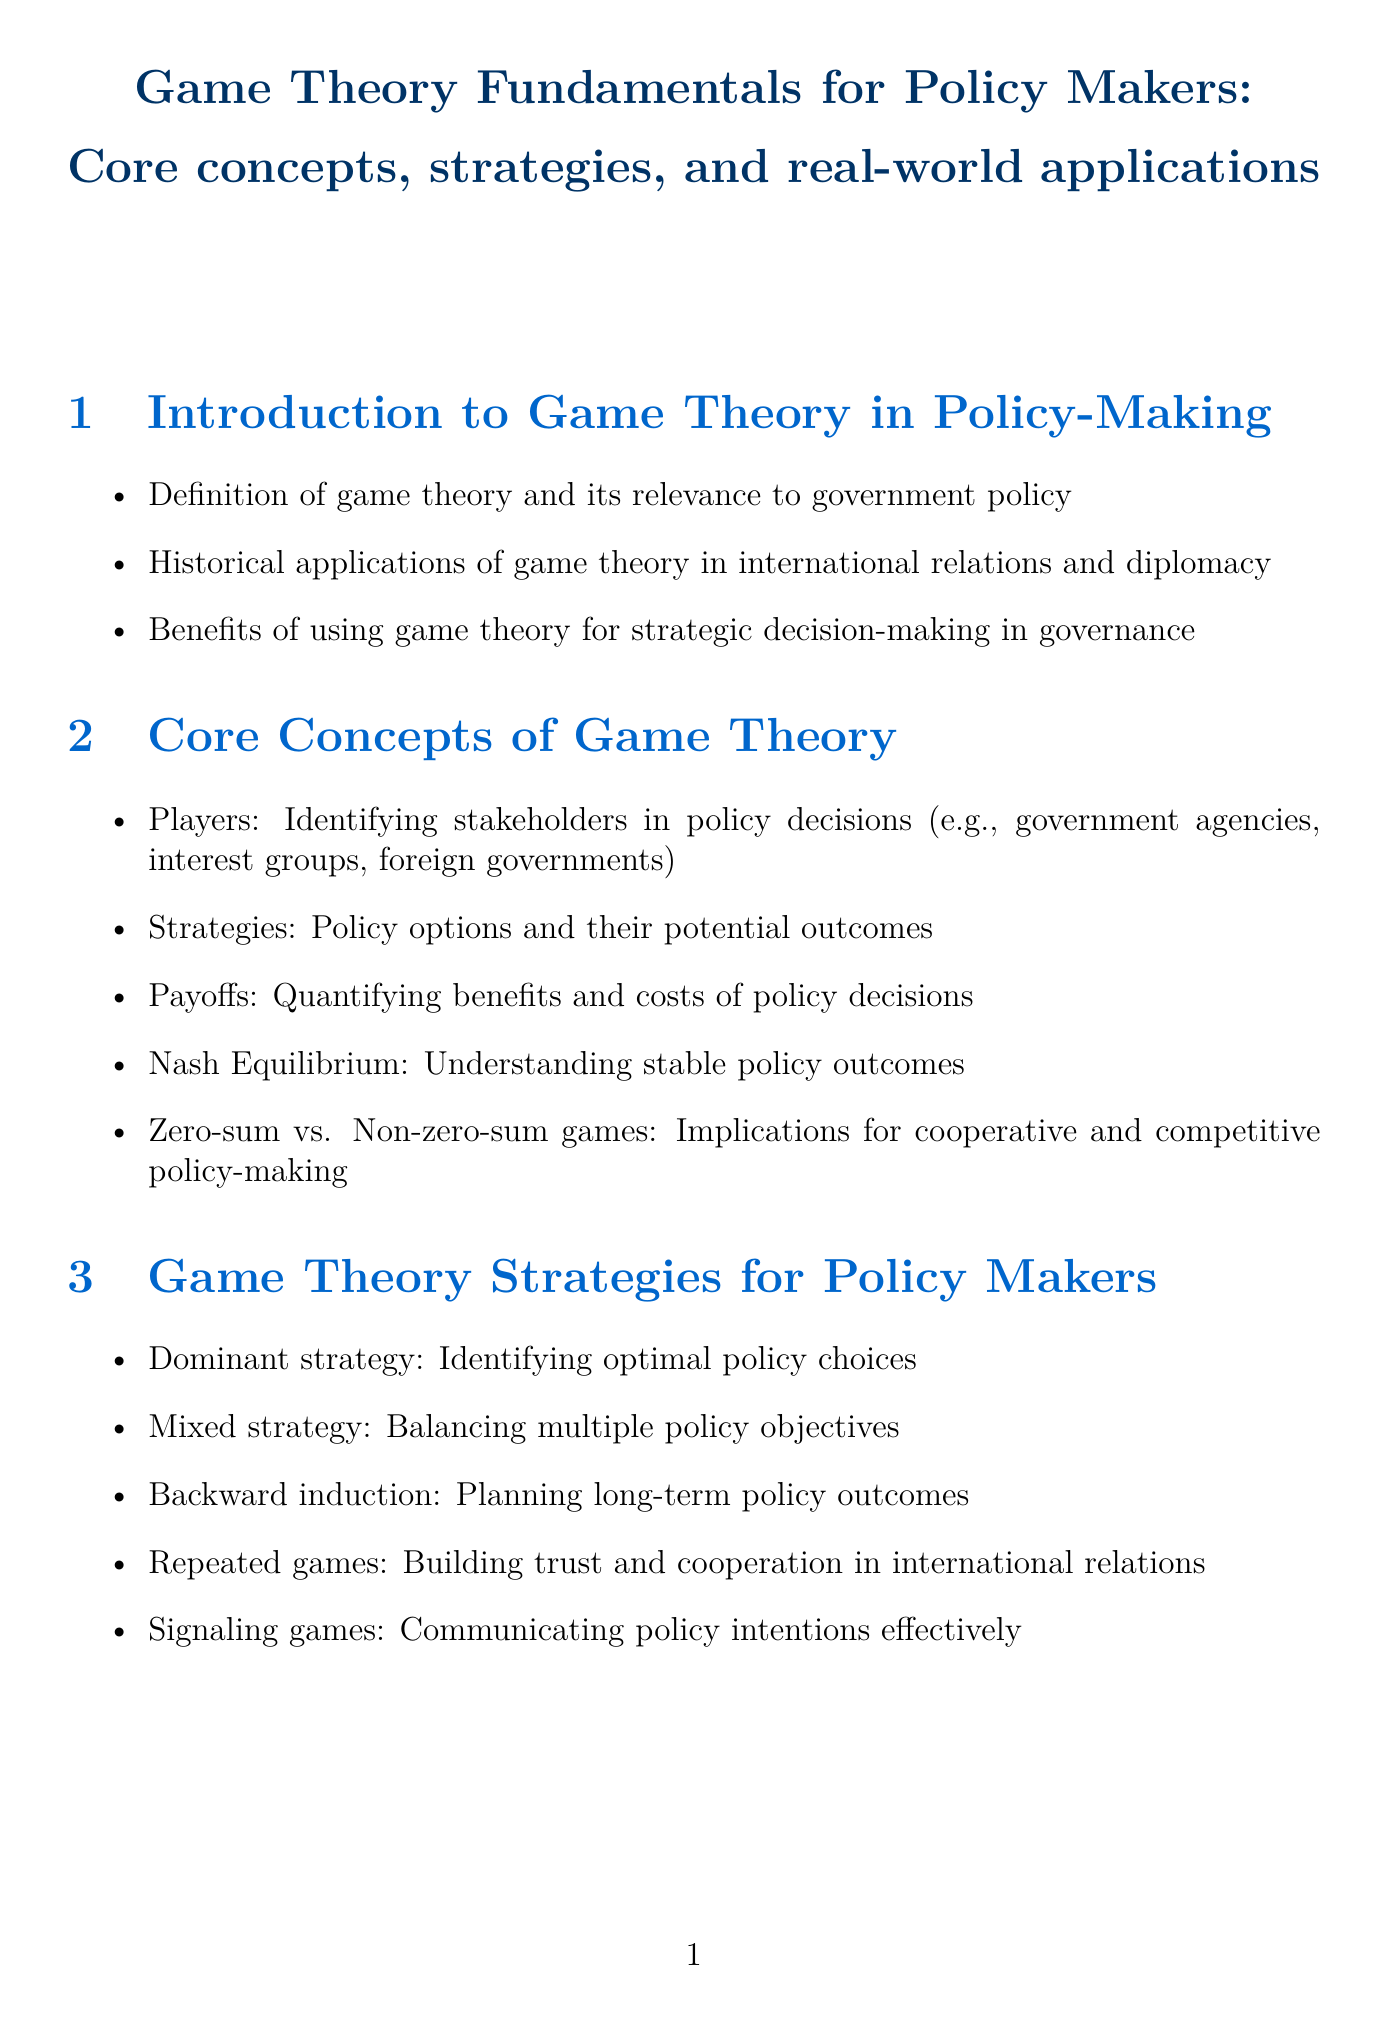What is the title of the manual? The title of the manual is clearly stated at the top of the document.
Answer: Game Theory Fundamentals for Policy Makers: Core concepts, strategies, and real-world applications What is one historical application of game theory mentioned? The document lists examples of historical applications within the content of the introduction section.
Answer: International relations What concept helps understand stable policy outcomes? The document provides terminology regarding concepts within game theory.
Answer: Nash Equilibrium What type of game is the Paris Agreement an example of? The document categorizes the Paris Agreement under real-world applications in government policy.
Answer: Coordination game What are mixed strategies used for in game theory? The document explains the purpose of mixed strategies in the context of policy-making.
Answer: Balancing multiple policy objectives What modeling technique is mentioned for uncertainty in policy outcomes? The relevant section lists various tools and techniques used in policy analysis.
Answer: Monte Carlo simulations What ethical consideration is discussed regarding game theory? The document notes several ethical considerations, particularly in the section focused on limitations.
Answer: Transparency and accountability What future trend involves machine learning? Future trends discussed in the document include various technological advancements related to policy analysis.
Answer: Artificial intelligence and machine learning How many case studies are presented in the document? The document enumerates the case studies in the relevant section.
Answer: Five 